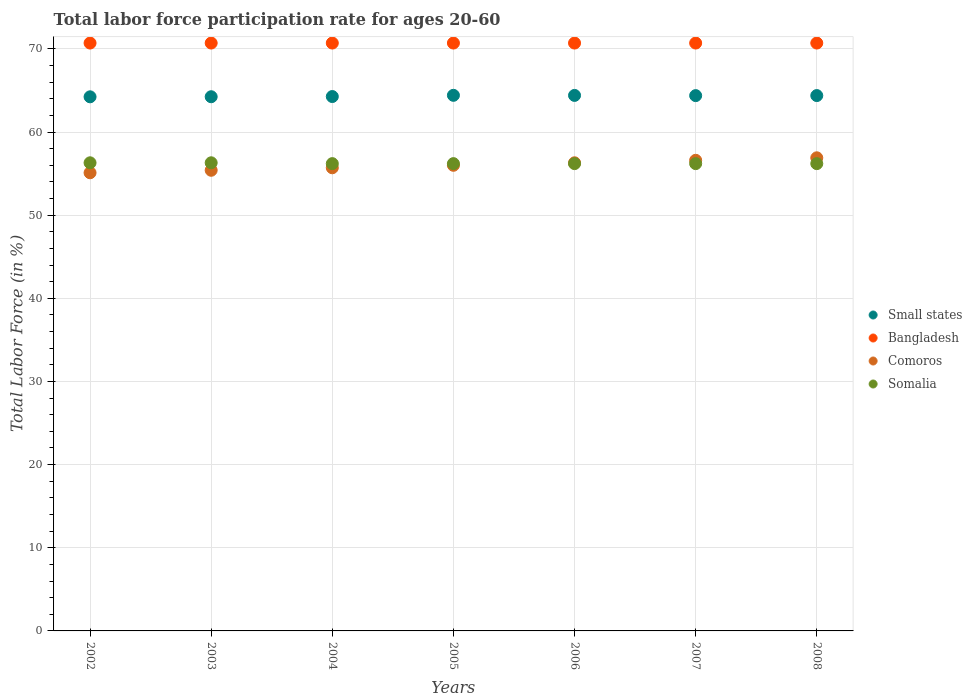How many different coloured dotlines are there?
Provide a short and direct response. 4. What is the labor force participation rate in Comoros in 2007?
Ensure brevity in your answer.  56.6. Across all years, what is the maximum labor force participation rate in Comoros?
Your answer should be compact. 56.9. Across all years, what is the minimum labor force participation rate in Small states?
Offer a terse response. 64.23. In which year was the labor force participation rate in Bangladesh minimum?
Give a very brief answer. 2002. What is the total labor force participation rate in Bangladesh in the graph?
Ensure brevity in your answer.  494.9. What is the difference between the labor force participation rate in Somalia in 2002 and that in 2006?
Give a very brief answer. 0.1. What is the difference between the labor force participation rate in Comoros in 2006 and the labor force participation rate in Somalia in 2008?
Your answer should be very brief. 0.1. What is the average labor force participation rate in Somalia per year?
Provide a succinct answer. 56.23. In the year 2007, what is the difference between the labor force participation rate in Small states and labor force participation rate in Somalia?
Give a very brief answer. 8.18. What is the ratio of the labor force participation rate in Small states in 2003 to that in 2004?
Make the answer very short. 1. Is the labor force participation rate in Comoros in 2005 less than that in 2006?
Your answer should be compact. Yes. Is the difference between the labor force participation rate in Small states in 2006 and 2007 greater than the difference between the labor force participation rate in Somalia in 2006 and 2007?
Your response must be concise. Yes. What is the difference between the highest and the second highest labor force participation rate in Small states?
Your answer should be compact. 0.01. What is the difference between the highest and the lowest labor force participation rate in Bangladesh?
Your answer should be very brief. 0. In how many years, is the labor force participation rate in Somalia greater than the average labor force participation rate in Somalia taken over all years?
Provide a succinct answer. 2. Is the sum of the labor force participation rate in Somalia in 2003 and 2008 greater than the maximum labor force participation rate in Small states across all years?
Offer a very short reply. Yes. Is the labor force participation rate in Somalia strictly greater than the labor force participation rate in Bangladesh over the years?
Your answer should be very brief. No. Are the values on the major ticks of Y-axis written in scientific E-notation?
Ensure brevity in your answer.  No. Does the graph contain grids?
Offer a terse response. Yes. How many legend labels are there?
Ensure brevity in your answer.  4. How are the legend labels stacked?
Your answer should be compact. Vertical. What is the title of the graph?
Offer a terse response. Total labor force participation rate for ages 20-60. Does "Dominican Republic" appear as one of the legend labels in the graph?
Offer a very short reply. No. What is the Total Labor Force (in %) in Small states in 2002?
Your answer should be very brief. 64.23. What is the Total Labor Force (in %) of Bangladesh in 2002?
Your answer should be compact. 70.7. What is the Total Labor Force (in %) of Comoros in 2002?
Ensure brevity in your answer.  55.1. What is the Total Labor Force (in %) of Somalia in 2002?
Offer a very short reply. 56.3. What is the Total Labor Force (in %) of Small states in 2003?
Your answer should be very brief. 64.24. What is the Total Labor Force (in %) of Bangladesh in 2003?
Provide a short and direct response. 70.7. What is the Total Labor Force (in %) of Comoros in 2003?
Provide a short and direct response. 55.4. What is the Total Labor Force (in %) of Somalia in 2003?
Provide a short and direct response. 56.3. What is the Total Labor Force (in %) of Small states in 2004?
Give a very brief answer. 64.27. What is the Total Labor Force (in %) in Bangladesh in 2004?
Keep it short and to the point. 70.7. What is the Total Labor Force (in %) in Comoros in 2004?
Ensure brevity in your answer.  55.7. What is the Total Labor Force (in %) of Somalia in 2004?
Make the answer very short. 56.2. What is the Total Labor Force (in %) in Small states in 2005?
Keep it short and to the point. 64.42. What is the Total Labor Force (in %) of Bangladesh in 2005?
Your answer should be compact. 70.7. What is the Total Labor Force (in %) in Comoros in 2005?
Provide a short and direct response. 56. What is the Total Labor Force (in %) in Somalia in 2005?
Offer a terse response. 56.2. What is the Total Labor Force (in %) of Small states in 2006?
Keep it short and to the point. 64.4. What is the Total Labor Force (in %) of Bangladesh in 2006?
Your answer should be very brief. 70.7. What is the Total Labor Force (in %) of Comoros in 2006?
Provide a short and direct response. 56.3. What is the Total Labor Force (in %) of Somalia in 2006?
Give a very brief answer. 56.2. What is the Total Labor Force (in %) of Small states in 2007?
Make the answer very short. 64.38. What is the Total Labor Force (in %) of Bangladesh in 2007?
Ensure brevity in your answer.  70.7. What is the Total Labor Force (in %) in Comoros in 2007?
Your answer should be very brief. 56.6. What is the Total Labor Force (in %) in Somalia in 2007?
Offer a very short reply. 56.2. What is the Total Labor Force (in %) in Small states in 2008?
Offer a terse response. 64.38. What is the Total Labor Force (in %) in Bangladesh in 2008?
Provide a succinct answer. 70.7. What is the Total Labor Force (in %) of Comoros in 2008?
Keep it short and to the point. 56.9. What is the Total Labor Force (in %) in Somalia in 2008?
Offer a very short reply. 56.2. Across all years, what is the maximum Total Labor Force (in %) in Small states?
Provide a succinct answer. 64.42. Across all years, what is the maximum Total Labor Force (in %) in Bangladesh?
Keep it short and to the point. 70.7. Across all years, what is the maximum Total Labor Force (in %) of Comoros?
Ensure brevity in your answer.  56.9. Across all years, what is the maximum Total Labor Force (in %) of Somalia?
Provide a succinct answer. 56.3. Across all years, what is the minimum Total Labor Force (in %) in Small states?
Your answer should be very brief. 64.23. Across all years, what is the minimum Total Labor Force (in %) of Bangladesh?
Your answer should be compact. 70.7. Across all years, what is the minimum Total Labor Force (in %) of Comoros?
Offer a very short reply. 55.1. Across all years, what is the minimum Total Labor Force (in %) of Somalia?
Ensure brevity in your answer.  56.2. What is the total Total Labor Force (in %) in Small states in the graph?
Your answer should be compact. 450.33. What is the total Total Labor Force (in %) in Bangladesh in the graph?
Your answer should be compact. 494.9. What is the total Total Labor Force (in %) of Comoros in the graph?
Ensure brevity in your answer.  392. What is the total Total Labor Force (in %) of Somalia in the graph?
Provide a succinct answer. 393.6. What is the difference between the Total Labor Force (in %) of Small states in 2002 and that in 2003?
Your answer should be compact. -0.01. What is the difference between the Total Labor Force (in %) of Bangladesh in 2002 and that in 2003?
Provide a short and direct response. 0. What is the difference between the Total Labor Force (in %) of Small states in 2002 and that in 2004?
Give a very brief answer. -0.03. What is the difference between the Total Labor Force (in %) in Comoros in 2002 and that in 2004?
Provide a short and direct response. -0.6. What is the difference between the Total Labor Force (in %) in Somalia in 2002 and that in 2004?
Make the answer very short. 0.1. What is the difference between the Total Labor Force (in %) in Small states in 2002 and that in 2005?
Your response must be concise. -0.18. What is the difference between the Total Labor Force (in %) of Bangladesh in 2002 and that in 2005?
Your answer should be very brief. 0. What is the difference between the Total Labor Force (in %) in Small states in 2002 and that in 2006?
Keep it short and to the point. -0.17. What is the difference between the Total Labor Force (in %) of Bangladesh in 2002 and that in 2006?
Your answer should be compact. 0. What is the difference between the Total Labor Force (in %) of Comoros in 2002 and that in 2006?
Your response must be concise. -1.2. What is the difference between the Total Labor Force (in %) in Small states in 2002 and that in 2007?
Your answer should be very brief. -0.14. What is the difference between the Total Labor Force (in %) of Somalia in 2002 and that in 2007?
Your answer should be compact. 0.1. What is the difference between the Total Labor Force (in %) of Small states in 2002 and that in 2008?
Ensure brevity in your answer.  -0.15. What is the difference between the Total Labor Force (in %) of Bangladesh in 2002 and that in 2008?
Keep it short and to the point. 0. What is the difference between the Total Labor Force (in %) of Small states in 2003 and that in 2004?
Provide a succinct answer. -0.02. What is the difference between the Total Labor Force (in %) of Bangladesh in 2003 and that in 2004?
Your response must be concise. 0. What is the difference between the Total Labor Force (in %) of Comoros in 2003 and that in 2004?
Ensure brevity in your answer.  -0.3. What is the difference between the Total Labor Force (in %) of Small states in 2003 and that in 2005?
Provide a short and direct response. -0.17. What is the difference between the Total Labor Force (in %) in Bangladesh in 2003 and that in 2005?
Your answer should be very brief. 0. What is the difference between the Total Labor Force (in %) of Somalia in 2003 and that in 2005?
Give a very brief answer. 0.1. What is the difference between the Total Labor Force (in %) of Small states in 2003 and that in 2006?
Offer a very short reply. -0.16. What is the difference between the Total Labor Force (in %) of Bangladesh in 2003 and that in 2006?
Your answer should be very brief. 0. What is the difference between the Total Labor Force (in %) of Comoros in 2003 and that in 2006?
Provide a succinct answer. -0.9. What is the difference between the Total Labor Force (in %) of Small states in 2003 and that in 2007?
Your answer should be compact. -0.13. What is the difference between the Total Labor Force (in %) in Bangladesh in 2003 and that in 2007?
Provide a short and direct response. 0. What is the difference between the Total Labor Force (in %) of Somalia in 2003 and that in 2007?
Offer a very short reply. 0.1. What is the difference between the Total Labor Force (in %) of Small states in 2003 and that in 2008?
Make the answer very short. -0.14. What is the difference between the Total Labor Force (in %) of Bangladesh in 2003 and that in 2008?
Your answer should be compact. 0. What is the difference between the Total Labor Force (in %) in Small states in 2004 and that in 2005?
Give a very brief answer. -0.15. What is the difference between the Total Labor Force (in %) of Somalia in 2004 and that in 2005?
Keep it short and to the point. 0. What is the difference between the Total Labor Force (in %) of Small states in 2004 and that in 2006?
Make the answer very short. -0.14. What is the difference between the Total Labor Force (in %) of Bangladesh in 2004 and that in 2006?
Provide a succinct answer. 0. What is the difference between the Total Labor Force (in %) of Somalia in 2004 and that in 2006?
Your response must be concise. 0. What is the difference between the Total Labor Force (in %) in Small states in 2004 and that in 2007?
Provide a succinct answer. -0.11. What is the difference between the Total Labor Force (in %) of Bangladesh in 2004 and that in 2007?
Your response must be concise. 0. What is the difference between the Total Labor Force (in %) in Small states in 2004 and that in 2008?
Offer a terse response. -0.12. What is the difference between the Total Labor Force (in %) in Bangladesh in 2004 and that in 2008?
Keep it short and to the point. 0. What is the difference between the Total Labor Force (in %) in Comoros in 2004 and that in 2008?
Keep it short and to the point. -1.2. What is the difference between the Total Labor Force (in %) of Small states in 2005 and that in 2006?
Offer a terse response. 0.01. What is the difference between the Total Labor Force (in %) in Comoros in 2005 and that in 2006?
Keep it short and to the point. -0.3. What is the difference between the Total Labor Force (in %) of Somalia in 2005 and that in 2006?
Offer a very short reply. 0. What is the difference between the Total Labor Force (in %) of Small states in 2005 and that in 2007?
Your response must be concise. 0.04. What is the difference between the Total Labor Force (in %) in Bangladesh in 2005 and that in 2007?
Your response must be concise. 0. What is the difference between the Total Labor Force (in %) in Comoros in 2005 and that in 2007?
Keep it short and to the point. -0.6. What is the difference between the Total Labor Force (in %) of Small states in 2005 and that in 2008?
Your answer should be very brief. 0.03. What is the difference between the Total Labor Force (in %) of Small states in 2006 and that in 2007?
Offer a terse response. 0.03. What is the difference between the Total Labor Force (in %) of Bangladesh in 2006 and that in 2007?
Your answer should be compact. 0. What is the difference between the Total Labor Force (in %) in Small states in 2006 and that in 2008?
Your answer should be very brief. 0.02. What is the difference between the Total Labor Force (in %) of Bangladesh in 2006 and that in 2008?
Keep it short and to the point. 0. What is the difference between the Total Labor Force (in %) of Small states in 2007 and that in 2008?
Offer a very short reply. -0.01. What is the difference between the Total Labor Force (in %) in Bangladesh in 2007 and that in 2008?
Keep it short and to the point. 0. What is the difference between the Total Labor Force (in %) of Comoros in 2007 and that in 2008?
Your response must be concise. -0.3. What is the difference between the Total Labor Force (in %) of Somalia in 2007 and that in 2008?
Your response must be concise. 0. What is the difference between the Total Labor Force (in %) of Small states in 2002 and the Total Labor Force (in %) of Bangladesh in 2003?
Ensure brevity in your answer.  -6.47. What is the difference between the Total Labor Force (in %) of Small states in 2002 and the Total Labor Force (in %) of Comoros in 2003?
Your answer should be very brief. 8.83. What is the difference between the Total Labor Force (in %) of Small states in 2002 and the Total Labor Force (in %) of Somalia in 2003?
Make the answer very short. 7.93. What is the difference between the Total Labor Force (in %) in Bangladesh in 2002 and the Total Labor Force (in %) in Comoros in 2003?
Offer a very short reply. 15.3. What is the difference between the Total Labor Force (in %) in Bangladesh in 2002 and the Total Labor Force (in %) in Somalia in 2003?
Offer a very short reply. 14.4. What is the difference between the Total Labor Force (in %) in Small states in 2002 and the Total Labor Force (in %) in Bangladesh in 2004?
Make the answer very short. -6.47. What is the difference between the Total Labor Force (in %) in Small states in 2002 and the Total Labor Force (in %) in Comoros in 2004?
Provide a succinct answer. 8.53. What is the difference between the Total Labor Force (in %) of Small states in 2002 and the Total Labor Force (in %) of Somalia in 2004?
Your response must be concise. 8.03. What is the difference between the Total Labor Force (in %) in Comoros in 2002 and the Total Labor Force (in %) in Somalia in 2004?
Make the answer very short. -1.1. What is the difference between the Total Labor Force (in %) of Small states in 2002 and the Total Labor Force (in %) of Bangladesh in 2005?
Your response must be concise. -6.47. What is the difference between the Total Labor Force (in %) of Small states in 2002 and the Total Labor Force (in %) of Comoros in 2005?
Your answer should be very brief. 8.23. What is the difference between the Total Labor Force (in %) in Small states in 2002 and the Total Labor Force (in %) in Somalia in 2005?
Your response must be concise. 8.03. What is the difference between the Total Labor Force (in %) in Bangladesh in 2002 and the Total Labor Force (in %) in Comoros in 2005?
Give a very brief answer. 14.7. What is the difference between the Total Labor Force (in %) in Small states in 2002 and the Total Labor Force (in %) in Bangladesh in 2006?
Provide a short and direct response. -6.47. What is the difference between the Total Labor Force (in %) in Small states in 2002 and the Total Labor Force (in %) in Comoros in 2006?
Provide a short and direct response. 7.93. What is the difference between the Total Labor Force (in %) of Small states in 2002 and the Total Labor Force (in %) of Somalia in 2006?
Make the answer very short. 8.03. What is the difference between the Total Labor Force (in %) of Bangladesh in 2002 and the Total Labor Force (in %) of Comoros in 2006?
Offer a very short reply. 14.4. What is the difference between the Total Labor Force (in %) of Bangladesh in 2002 and the Total Labor Force (in %) of Somalia in 2006?
Your response must be concise. 14.5. What is the difference between the Total Labor Force (in %) in Comoros in 2002 and the Total Labor Force (in %) in Somalia in 2006?
Ensure brevity in your answer.  -1.1. What is the difference between the Total Labor Force (in %) in Small states in 2002 and the Total Labor Force (in %) in Bangladesh in 2007?
Your answer should be very brief. -6.47. What is the difference between the Total Labor Force (in %) of Small states in 2002 and the Total Labor Force (in %) of Comoros in 2007?
Keep it short and to the point. 7.63. What is the difference between the Total Labor Force (in %) in Small states in 2002 and the Total Labor Force (in %) in Somalia in 2007?
Offer a terse response. 8.03. What is the difference between the Total Labor Force (in %) of Bangladesh in 2002 and the Total Labor Force (in %) of Comoros in 2007?
Your answer should be compact. 14.1. What is the difference between the Total Labor Force (in %) in Comoros in 2002 and the Total Labor Force (in %) in Somalia in 2007?
Make the answer very short. -1.1. What is the difference between the Total Labor Force (in %) in Small states in 2002 and the Total Labor Force (in %) in Bangladesh in 2008?
Keep it short and to the point. -6.47. What is the difference between the Total Labor Force (in %) of Small states in 2002 and the Total Labor Force (in %) of Comoros in 2008?
Keep it short and to the point. 7.33. What is the difference between the Total Labor Force (in %) of Small states in 2002 and the Total Labor Force (in %) of Somalia in 2008?
Your answer should be very brief. 8.03. What is the difference between the Total Labor Force (in %) of Bangladesh in 2002 and the Total Labor Force (in %) of Comoros in 2008?
Ensure brevity in your answer.  13.8. What is the difference between the Total Labor Force (in %) in Small states in 2003 and the Total Labor Force (in %) in Bangladesh in 2004?
Give a very brief answer. -6.46. What is the difference between the Total Labor Force (in %) in Small states in 2003 and the Total Labor Force (in %) in Comoros in 2004?
Give a very brief answer. 8.54. What is the difference between the Total Labor Force (in %) in Small states in 2003 and the Total Labor Force (in %) in Somalia in 2004?
Ensure brevity in your answer.  8.04. What is the difference between the Total Labor Force (in %) in Bangladesh in 2003 and the Total Labor Force (in %) in Comoros in 2004?
Ensure brevity in your answer.  15. What is the difference between the Total Labor Force (in %) of Small states in 2003 and the Total Labor Force (in %) of Bangladesh in 2005?
Your answer should be very brief. -6.46. What is the difference between the Total Labor Force (in %) in Small states in 2003 and the Total Labor Force (in %) in Comoros in 2005?
Provide a succinct answer. 8.24. What is the difference between the Total Labor Force (in %) in Small states in 2003 and the Total Labor Force (in %) in Somalia in 2005?
Ensure brevity in your answer.  8.04. What is the difference between the Total Labor Force (in %) in Comoros in 2003 and the Total Labor Force (in %) in Somalia in 2005?
Your answer should be compact. -0.8. What is the difference between the Total Labor Force (in %) of Small states in 2003 and the Total Labor Force (in %) of Bangladesh in 2006?
Make the answer very short. -6.46. What is the difference between the Total Labor Force (in %) of Small states in 2003 and the Total Labor Force (in %) of Comoros in 2006?
Your answer should be very brief. 7.94. What is the difference between the Total Labor Force (in %) of Small states in 2003 and the Total Labor Force (in %) of Somalia in 2006?
Make the answer very short. 8.04. What is the difference between the Total Labor Force (in %) of Bangladesh in 2003 and the Total Labor Force (in %) of Comoros in 2006?
Keep it short and to the point. 14.4. What is the difference between the Total Labor Force (in %) of Bangladesh in 2003 and the Total Labor Force (in %) of Somalia in 2006?
Ensure brevity in your answer.  14.5. What is the difference between the Total Labor Force (in %) in Comoros in 2003 and the Total Labor Force (in %) in Somalia in 2006?
Make the answer very short. -0.8. What is the difference between the Total Labor Force (in %) of Small states in 2003 and the Total Labor Force (in %) of Bangladesh in 2007?
Keep it short and to the point. -6.46. What is the difference between the Total Labor Force (in %) in Small states in 2003 and the Total Labor Force (in %) in Comoros in 2007?
Offer a terse response. 7.64. What is the difference between the Total Labor Force (in %) of Small states in 2003 and the Total Labor Force (in %) of Somalia in 2007?
Your answer should be very brief. 8.04. What is the difference between the Total Labor Force (in %) in Bangladesh in 2003 and the Total Labor Force (in %) in Comoros in 2007?
Keep it short and to the point. 14.1. What is the difference between the Total Labor Force (in %) of Bangladesh in 2003 and the Total Labor Force (in %) of Somalia in 2007?
Provide a short and direct response. 14.5. What is the difference between the Total Labor Force (in %) in Comoros in 2003 and the Total Labor Force (in %) in Somalia in 2007?
Provide a succinct answer. -0.8. What is the difference between the Total Labor Force (in %) in Small states in 2003 and the Total Labor Force (in %) in Bangladesh in 2008?
Offer a very short reply. -6.46. What is the difference between the Total Labor Force (in %) in Small states in 2003 and the Total Labor Force (in %) in Comoros in 2008?
Your answer should be compact. 7.34. What is the difference between the Total Labor Force (in %) in Small states in 2003 and the Total Labor Force (in %) in Somalia in 2008?
Offer a terse response. 8.04. What is the difference between the Total Labor Force (in %) of Bangladesh in 2003 and the Total Labor Force (in %) of Comoros in 2008?
Provide a succinct answer. 13.8. What is the difference between the Total Labor Force (in %) of Small states in 2004 and the Total Labor Force (in %) of Bangladesh in 2005?
Provide a short and direct response. -6.43. What is the difference between the Total Labor Force (in %) in Small states in 2004 and the Total Labor Force (in %) in Comoros in 2005?
Your answer should be compact. 8.27. What is the difference between the Total Labor Force (in %) of Small states in 2004 and the Total Labor Force (in %) of Somalia in 2005?
Keep it short and to the point. 8.07. What is the difference between the Total Labor Force (in %) in Bangladesh in 2004 and the Total Labor Force (in %) in Somalia in 2005?
Your answer should be compact. 14.5. What is the difference between the Total Labor Force (in %) in Comoros in 2004 and the Total Labor Force (in %) in Somalia in 2005?
Your answer should be very brief. -0.5. What is the difference between the Total Labor Force (in %) of Small states in 2004 and the Total Labor Force (in %) of Bangladesh in 2006?
Give a very brief answer. -6.43. What is the difference between the Total Labor Force (in %) of Small states in 2004 and the Total Labor Force (in %) of Comoros in 2006?
Your answer should be very brief. 7.97. What is the difference between the Total Labor Force (in %) of Small states in 2004 and the Total Labor Force (in %) of Somalia in 2006?
Make the answer very short. 8.07. What is the difference between the Total Labor Force (in %) in Comoros in 2004 and the Total Labor Force (in %) in Somalia in 2006?
Offer a terse response. -0.5. What is the difference between the Total Labor Force (in %) of Small states in 2004 and the Total Labor Force (in %) of Bangladesh in 2007?
Your response must be concise. -6.43. What is the difference between the Total Labor Force (in %) of Small states in 2004 and the Total Labor Force (in %) of Comoros in 2007?
Your answer should be very brief. 7.67. What is the difference between the Total Labor Force (in %) in Small states in 2004 and the Total Labor Force (in %) in Somalia in 2007?
Ensure brevity in your answer.  8.07. What is the difference between the Total Labor Force (in %) in Small states in 2004 and the Total Labor Force (in %) in Bangladesh in 2008?
Offer a terse response. -6.43. What is the difference between the Total Labor Force (in %) of Small states in 2004 and the Total Labor Force (in %) of Comoros in 2008?
Keep it short and to the point. 7.37. What is the difference between the Total Labor Force (in %) of Small states in 2004 and the Total Labor Force (in %) of Somalia in 2008?
Provide a succinct answer. 8.07. What is the difference between the Total Labor Force (in %) of Bangladesh in 2004 and the Total Labor Force (in %) of Comoros in 2008?
Your answer should be compact. 13.8. What is the difference between the Total Labor Force (in %) of Small states in 2005 and the Total Labor Force (in %) of Bangladesh in 2006?
Your answer should be compact. -6.28. What is the difference between the Total Labor Force (in %) in Small states in 2005 and the Total Labor Force (in %) in Comoros in 2006?
Make the answer very short. 8.12. What is the difference between the Total Labor Force (in %) in Small states in 2005 and the Total Labor Force (in %) in Somalia in 2006?
Offer a terse response. 8.22. What is the difference between the Total Labor Force (in %) in Comoros in 2005 and the Total Labor Force (in %) in Somalia in 2006?
Give a very brief answer. -0.2. What is the difference between the Total Labor Force (in %) of Small states in 2005 and the Total Labor Force (in %) of Bangladesh in 2007?
Your answer should be very brief. -6.28. What is the difference between the Total Labor Force (in %) of Small states in 2005 and the Total Labor Force (in %) of Comoros in 2007?
Give a very brief answer. 7.82. What is the difference between the Total Labor Force (in %) of Small states in 2005 and the Total Labor Force (in %) of Somalia in 2007?
Ensure brevity in your answer.  8.22. What is the difference between the Total Labor Force (in %) in Comoros in 2005 and the Total Labor Force (in %) in Somalia in 2007?
Make the answer very short. -0.2. What is the difference between the Total Labor Force (in %) in Small states in 2005 and the Total Labor Force (in %) in Bangladesh in 2008?
Your answer should be very brief. -6.28. What is the difference between the Total Labor Force (in %) in Small states in 2005 and the Total Labor Force (in %) in Comoros in 2008?
Offer a very short reply. 7.52. What is the difference between the Total Labor Force (in %) of Small states in 2005 and the Total Labor Force (in %) of Somalia in 2008?
Provide a succinct answer. 8.22. What is the difference between the Total Labor Force (in %) of Bangladesh in 2005 and the Total Labor Force (in %) of Somalia in 2008?
Offer a very short reply. 14.5. What is the difference between the Total Labor Force (in %) of Comoros in 2005 and the Total Labor Force (in %) of Somalia in 2008?
Provide a succinct answer. -0.2. What is the difference between the Total Labor Force (in %) in Small states in 2006 and the Total Labor Force (in %) in Bangladesh in 2007?
Provide a short and direct response. -6.3. What is the difference between the Total Labor Force (in %) in Small states in 2006 and the Total Labor Force (in %) in Comoros in 2007?
Offer a terse response. 7.8. What is the difference between the Total Labor Force (in %) in Small states in 2006 and the Total Labor Force (in %) in Somalia in 2007?
Your answer should be compact. 8.2. What is the difference between the Total Labor Force (in %) in Comoros in 2006 and the Total Labor Force (in %) in Somalia in 2007?
Your answer should be very brief. 0.1. What is the difference between the Total Labor Force (in %) in Small states in 2006 and the Total Labor Force (in %) in Bangladesh in 2008?
Your answer should be compact. -6.3. What is the difference between the Total Labor Force (in %) of Small states in 2006 and the Total Labor Force (in %) of Comoros in 2008?
Your answer should be compact. 7.5. What is the difference between the Total Labor Force (in %) of Small states in 2006 and the Total Labor Force (in %) of Somalia in 2008?
Your answer should be very brief. 8.2. What is the difference between the Total Labor Force (in %) in Comoros in 2006 and the Total Labor Force (in %) in Somalia in 2008?
Your answer should be compact. 0.1. What is the difference between the Total Labor Force (in %) of Small states in 2007 and the Total Labor Force (in %) of Bangladesh in 2008?
Provide a short and direct response. -6.32. What is the difference between the Total Labor Force (in %) of Small states in 2007 and the Total Labor Force (in %) of Comoros in 2008?
Your answer should be compact. 7.48. What is the difference between the Total Labor Force (in %) in Small states in 2007 and the Total Labor Force (in %) in Somalia in 2008?
Offer a very short reply. 8.18. What is the difference between the Total Labor Force (in %) of Bangladesh in 2007 and the Total Labor Force (in %) of Somalia in 2008?
Your answer should be compact. 14.5. What is the difference between the Total Labor Force (in %) in Comoros in 2007 and the Total Labor Force (in %) in Somalia in 2008?
Offer a very short reply. 0.4. What is the average Total Labor Force (in %) in Small states per year?
Offer a very short reply. 64.33. What is the average Total Labor Force (in %) of Bangladesh per year?
Provide a succinct answer. 70.7. What is the average Total Labor Force (in %) of Comoros per year?
Keep it short and to the point. 56. What is the average Total Labor Force (in %) in Somalia per year?
Provide a succinct answer. 56.23. In the year 2002, what is the difference between the Total Labor Force (in %) of Small states and Total Labor Force (in %) of Bangladesh?
Make the answer very short. -6.47. In the year 2002, what is the difference between the Total Labor Force (in %) in Small states and Total Labor Force (in %) in Comoros?
Your response must be concise. 9.13. In the year 2002, what is the difference between the Total Labor Force (in %) in Small states and Total Labor Force (in %) in Somalia?
Ensure brevity in your answer.  7.93. In the year 2003, what is the difference between the Total Labor Force (in %) of Small states and Total Labor Force (in %) of Bangladesh?
Offer a terse response. -6.46. In the year 2003, what is the difference between the Total Labor Force (in %) in Small states and Total Labor Force (in %) in Comoros?
Your answer should be compact. 8.84. In the year 2003, what is the difference between the Total Labor Force (in %) in Small states and Total Labor Force (in %) in Somalia?
Give a very brief answer. 7.94. In the year 2003, what is the difference between the Total Labor Force (in %) in Comoros and Total Labor Force (in %) in Somalia?
Offer a very short reply. -0.9. In the year 2004, what is the difference between the Total Labor Force (in %) in Small states and Total Labor Force (in %) in Bangladesh?
Offer a very short reply. -6.43. In the year 2004, what is the difference between the Total Labor Force (in %) of Small states and Total Labor Force (in %) of Comoros?
Keep it short and to the point. 8.57. In the year 2004, what is the difference between the Total Labor Force (in %) of Small states and Total Labor Force (in %) of Somalia?
Make the answer very short. 8.07. In the year 2004, what is the difference between the Total Labor Force (in %) of Bangladesh and Total Labor Force (in %) of Comoros?
Your response must be concise. 15. In the year 2004, what is the difference between the Total Labor Force (in %) in Bangladesh and Total Labor Force (in %) in Somalia?
Provide a succinct answer. 14.5. In the year 2005, what is the difference between the Total Labor Force (in %) in Small states and Total Labor Force (in %) in Bangladesh?
Make the answer very short. -6.28. In the year 2005, what is the difference between the Total Labor Force (in %) of Small states and Total Labor Force (in %) of Comoros?
Provide a short and direct response. 8.42. In the year 2005, what is the difference between the Total Labor Force (in %) in Small states and Total Labor Force (in %) in Somalia?
Provide a succinct answer. 8.22. In the year 2005, what is the difference between the Total Labor Force (in %) of Bangladesh and Total Labor Force (in %) of Comoros?
Make the answer very short. 14.7. In the year 2005, what is the difference between the Total Labor Force (in %) of Comoros and Total Labor Force (in %) of Somalia?
Your answer should be very brief. -0.2. In the year 2006, what is the difference between the Total Labor Force (in %) of Small states and Total Labor Force (in %) of Bangladesh?
Offer a terse response. -6.3. In the year 2006, what is the difference between the Total Labor Force (in %) in Small states and Total Labor Force (in %) in Comoros?
Give a very brief answer. 8.1. In the year 2006, what is the difference between the Total Labor Force (in %) of Small states and Total Labor Force (in %) of Somalia?
Keep it short and to the point. 8.2. In the year 2006, what is the difference between the Total Labor Force (in %) of Bangladesh and Total Labor Force (in %) of Comoros?
Your answer should be very brief. 14.4. In the year 2006, what is the difference between the Total Labor Force (in %) in Comoros and Total Labor Force (in %) in Somalia?
Keep it short and to the point. 0.1. In the year 2007, what is the difference between the Total Labor Force (in %) of Small states and Total Labor Force (in %) of Bangladesh?
Offer a very short reply. -6.32. In the year 2007, what is the difference between the Total Labor Force (in %) in Small states and Total Labor Force (in %) in Comoros?
Offer a terse response. 7.78. In the year 2007, what is the difference between the Total Labor Force (in %) in Small states and Total Labor Force (in %) in Somalia?
Ensure brevity in your answer.  8.18. In the year 2008, what is the difference between the Total Labor Force (in %) of Small states and Total Labor Force (in %) of Bangladesh?
Provide a succinct answer. -6.32. In the year 2008, what is the difference between the Total Labor Force (in %) in Small states and Total Labor Force (in %) in Comoros?
Offer a terse response. 7.48. In the year 2008, what is the difference between the Total Labor Force (in %) of Small states and Total Labor Force (in %) of Somalia?
Offer a very short reply. 8.18. In the year 2008, what is the difference between the Total Labor Force (in %) of Bangladesh and Total Labor Force (in %) of Comoros?
Ensure brevity in your answer.  13.8. In the year 2008, what is the difference between the Total Labor Force (in %) of Comoros and Total Labor Force (in %) of Somalia?
Give a very brief answer. 0.7. What is the ratio of the Total Labor Force (in %) of Somalia in 2002 to that in 2003?
Ensure brevity in your answer.  1. What is the ratio of the Total Labor Force (in %) of Somalia in 2002 to that in 2004?
Provide a short and direct response. 1. What is the ratio of the Total Labor Force (in %) of Bangladesh in 2002 to that in 2005?
Offer a terse response. 1. What is the ratio of the Total Labor Force (in %) of Comoros in 2002 to that in 2005?
Your answer should be compact. 0.98. What is the ratio of the Total Labor Force (in %) in Bangladesh in 2002 to that in 2006?
Make the answer very short. 1. What is the ratio of the Total Labor Force (in %) in Comoros in 2002 to that in 2006?
Offer a terse response. 0.98. What is the ratio of the Total Labor Force (in %) of Bangladesh in 2002 to that in 2007?
Ensure brevity in your answer.  1. What is the ratio of the Total Labor Force (in %) of Comoros in 2002 to that in 2007?
Offer a very short reply. 0.97. What is the ratio of the Total Labor Force (in %) in Somalia in 2002 to that in 2007?
Your response must be concise. 1. What is the ratio of the Total Labor Force (in %) in Small states in 2002 to that in 2008?
Give a very brief answer. 1. What is the ratio of the Total Labor Force (in %) in Bangladesh in 2002 to that in 2008?
Your response must be concise. 1. What is the ratio of the Total Labor Force (in %) in Comoros in 2002 to that in 2008?
Ensure brevity in your answer.  0.97. What is the ratio of the Total Labor Force (in %) of Somalia in 2002 to that in 2008?
Ensure brevity in your answer.  1. What is the ratio of the Total Labor Force (in %) in Small states in 2003 to that in 2004?
Provide a short and direct response. 1. What is the ratio of the Total Labor Force (in %) of Somalia in 2003 to that in 2004?
Offer a very short reply. 1. What is the ratio of the Total Labor Force (in %) of Comoros in 2003 to that in 2005?
Provide a succinct answer. 0.99. What is the ratio of the Total Labor Force (in %) of Small states in 2003 to that in 2006?
Your response must be concise. 1. What is the ratio of the Total Labor Force (in %) in Bangladesh in 2003 to that in 2006?
Keep it short and to the point. 1. What is the ratio of the Total Labor Force (in %) of Small states in 2003 to that in 2007?
Give a very brief answer. 1. What is the ratio of the Total Labor Force (in %) in Bangladesh in 2003 to that in 2007?
Give a very brief answer. 1. What is the ratio of the Total Labor Force (in %) in Comoros in 2003 to that in 2007?
Offer a very short reply. 0.98. What is the ratio of the Total Labor Force (in %) in Bangladesh in 2003 to that in 2008?
Give a very brief answer. 1. What is the ratio of the Total Labor Force (in %) in Comoros in 2003 to that in 2008?
Keep it short and to the point. 0.97. What is the ratio of the Total Labor Force (in %) in Small states in 2004 to that in 2005?
Provide a succinct answer. 1. What is the ratio of the Total Labor Force (in %) in Bangladesh in 2004 to that in 2005?
Offer a very short reply. 1. What is the ratio of the Total Labor Force (in %) of Somalia in 2004 to that in 2005?
Provide a short and direct response. 1. What is the ratio of the Total Labor Force (in %) in Comoros in 2004 to that in 2006?
Make the answer very short. 0.99. What is the ratio of the Total Labor Force (in %) in Somalia in 2004 to that in 2006?
Your answer should be compact. 1. What is the ratio of the Total Labor Force (in %) in Bangladesh in 2004 to that in 2007?
Offer a terse response. 1. What is the ratio of the Total Labor Force (in %) in Comoros in 2004 to that in 2007?
Your answer should be very brief. 0.98. What is the ratio of the Total Labor Force (in %) in Somalia in 2004 to that in 2007?
Keep it short and to the point. 1. What is the ratio of the Total Labor Force (in %) in Bangladesh in 2004 to that in 2008?
Provide a succinct answer. 1. What is the ratio of the Total Labor Force (in %) of Comoros in 2004 to that in 2008?
Ensure brevity in your answer.  0.98. What is the ratio of the Total Labor Force (in %) in Small states in 2005 to that in 2006?
Make the answer very short. 1. What is the ratio of the Total Labor Force (in %) in Bangladesh in 2005 to that in 2006?
Offer a very short reply. 1. What is the ratio of the Total Labor Force (in %) in Comoros in 2005 to that in 2007?
Keep it short and to the point. 0.99. What is the ratio of the Total Labor Force (in %) of Somalia in 2005 to that in 2007?
Give a very brief answer. 1. What is the ratio of the Total Labor Force (in %) in Comoros in 2005 to that in 2008?
Provide a short and direct response. 0.98. What is the ratio of the Total Labor Force (in %) of Small states in 2006 to that in 2007?
Provide a short and direct response. 1. What is the ratio of the Total Labor Force (in %) of Bangladesh in 2006 to that in 2007?
Your answer should be very brief. 1. What is the ratio of the Total Labor Force (in %) of Small states in 2006 to that in 2008?
Offer a terse response. 1. What is the ratio of the Total Labor Force (in %) of Bangladesh in 2006 to that in 2008?
Provide a short and direct response. 1. What is the ratio of the Total Labor Force (in %) in Somalia in 2006 to that in 2008?
Give a very brief answer. 1. What is the ratio of the Total Labor Force (in %) in Small states in 2007 to that in 2008?
Your response must be concise. 1. What is the ratio of the Total Labor Force (in %) of Bangladesh in 2007 to that in 2008?
Ensure brevity in your answer.  1. What is the ratio of the Total Labor Force (in %) in Somalia in 2007 to that in 2008?
Your answer should be compact. 1. What is the difference between the highest and the second highest Total Labor Force (in %) in Small states?
Make the answer very short. 0.01. What is the difference between the highest and the second highest Total Labor Force (in %) in Bangladesh?
Make the answer very short. 0. What is the difference between the highest and the lowest Total Labor Force (in %) in Small states?
Provide a succinct answer. 0.18. What is the difference between the highest and the lowest Total Labor Force (in %) in Bangladesh?
Keep it short and to the point. 0. What is the difference between the highest and the lowest Total Labor Force (in %) in Somalia?
Offer a very short reply. 0.1. 